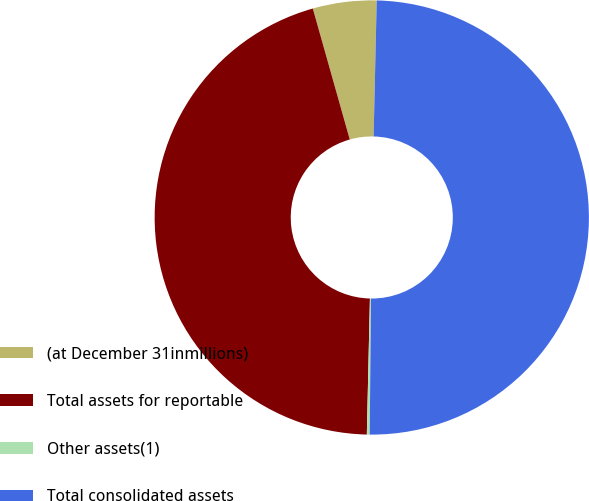<chart> <loc_0><loc_0><loc_500><loc_500><pie_chart><fcel>(at December 31inmillions)<fcel>Total assets for reportable<fcel>Other assets(1)<fcel>Total consolidated assets<nl><fcel>4.74%<fcel>45.26%<fcel>0.21%<fcel>49.79%<nl></chart> 